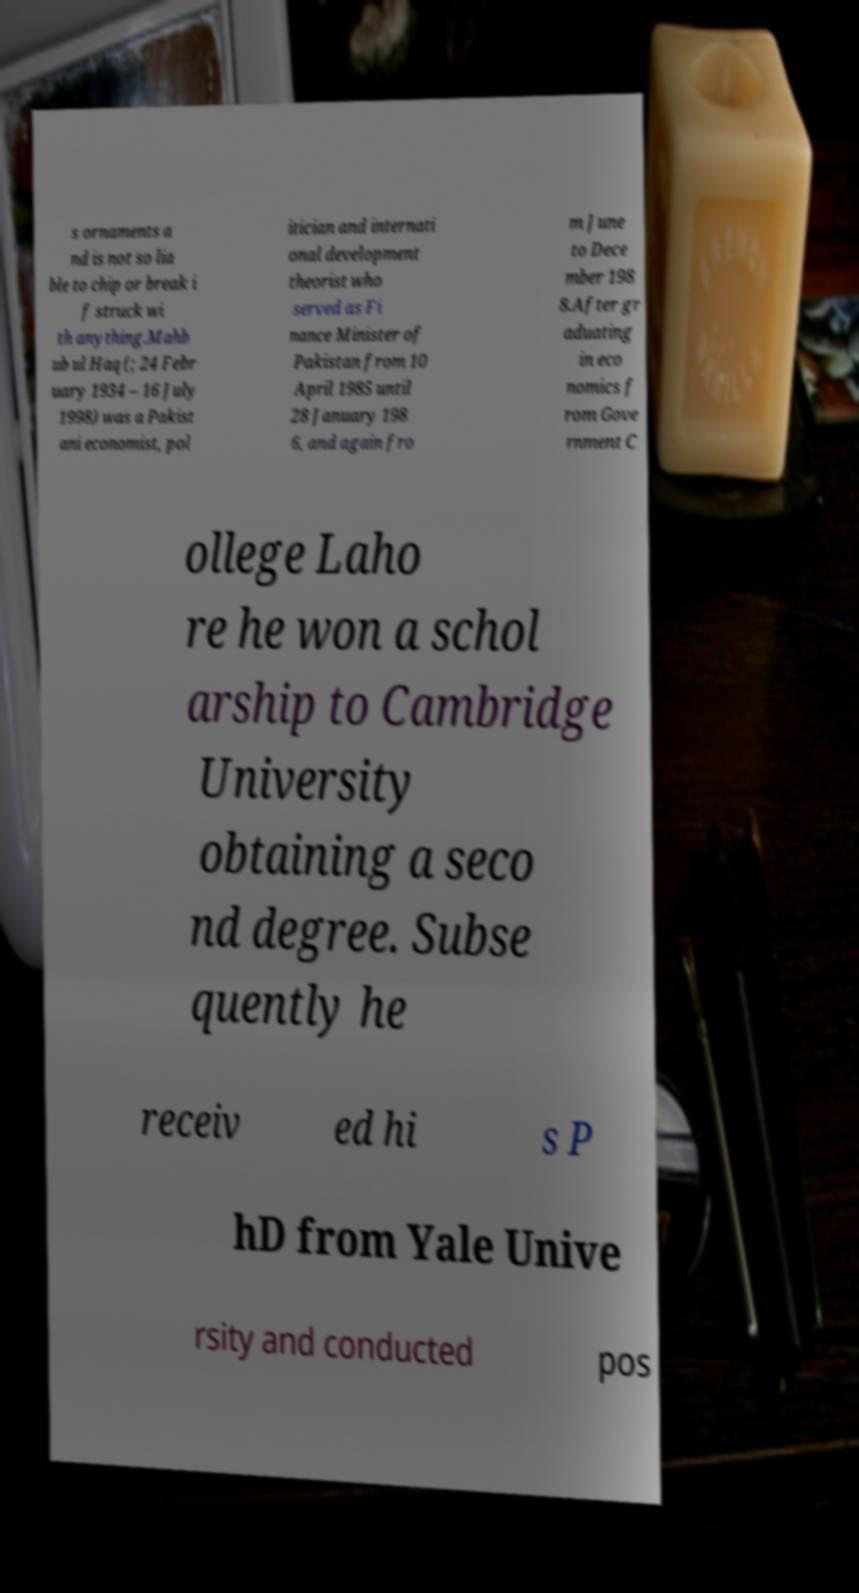There's text embedded in this image that I need extracted. Can you transcribe it verbatim? s ornaments a nd is not so lia ble to chip or break i f struck wi th anything.Mahb ub ul Haq (; 24 Febr uary 1934 – 16 July 1998) was a Pakist ani economist, pol itician and internati onal development theorist who served as Fi nance Minister of Pakistan from 10 April 1985 until 28 January 198 6, and again fro m June to Dece mber 198 8.After gr aduating in eco nomics f rom Gove rnment C ollege Laho re he won a schol arship to Cambridge University obtaining a seco nd degree. Subse quently he receiv ed hi s P hD from Yale Unive rsity and conducted pos 